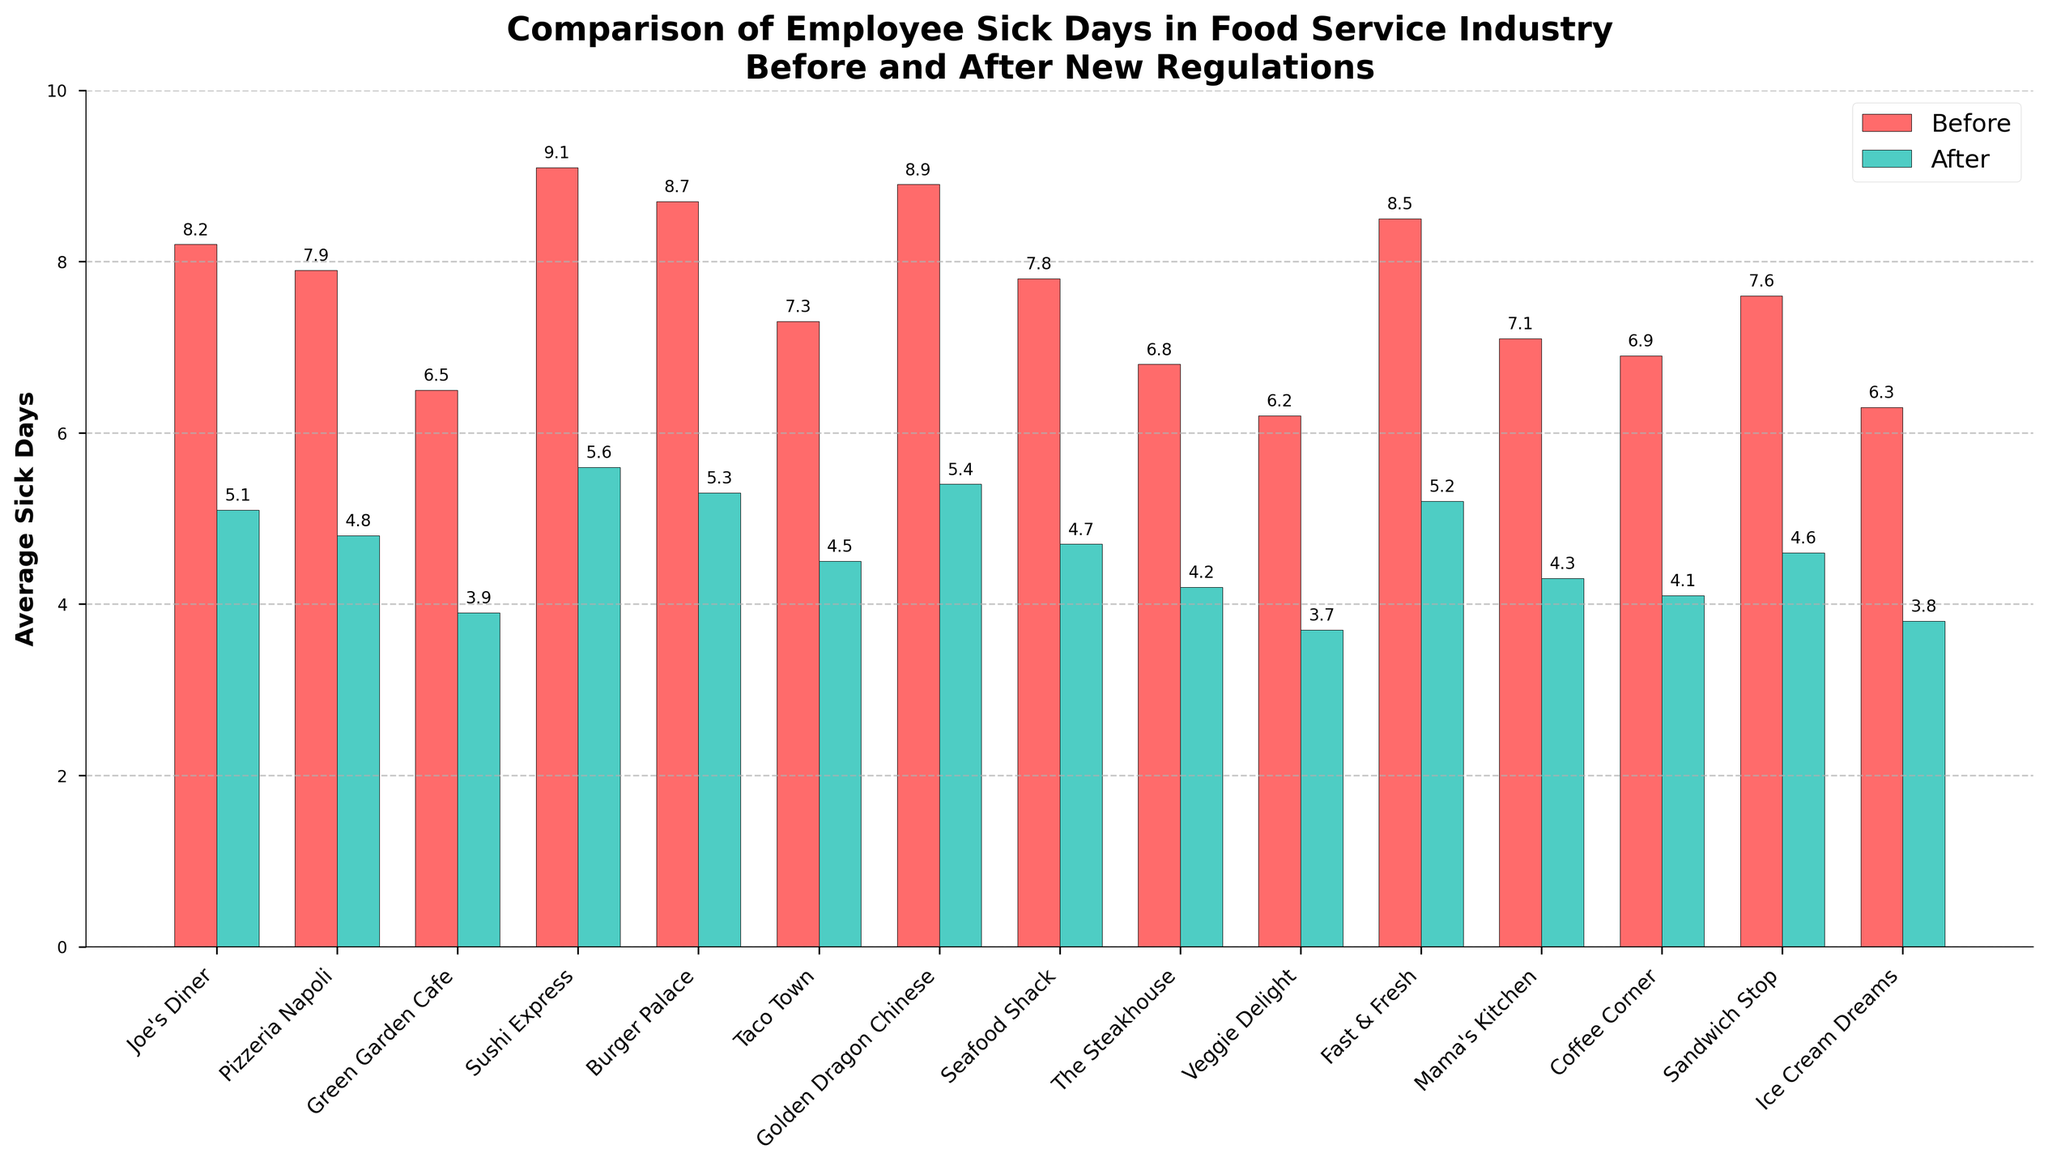What is the overall trend in average sick days before and after the new regulations across all restaurants? The plot shows that the height of the green bars (after regulations) is consistently lower than the height of the red bars (before regulations) for each restaurant, indicating a decrease in average sick days for all restaurants.
Answer: Decrease Which restaurant had the highest average sick days before the new regulations? Looking at the red bars, the tallest one corresponds to "Sushi Express," indicating it had the highest average sick days before the new regulations.
Answer: Sushi Express What was the average reduction in sick days for "Golden Dragon Chinese"? The red bar for "Golden Dragon Chinese" shows an average of 8.9 days before, and the green bar shows 5.4 days after. The reduction is calculated as 8.9 - 5.4.
Answer: 3.5 days Which restaurants had an average sick day reduction greater than 3 days? By comparing the height difference between red and green bars, "Joe's Diner," "Pizzeria Napoli," "Sushi Express," "Burger Palace," "Golden Dragon Chinese," and "Fast & Fresh" show reductions greater than 3 days.
Answer: Joe's Diner, Pizzeria Napoli, Sushi Express, Burger Palace, Golden Dragon Chinese, Fast & Fresh What is the approximate total average sick days saved after the implementation for all restaurants combined? Sum the average reduction in sick days for each restaurant: (8.2-5.1) + (7.9-4.8) + (6.5-3.9) + (9.1-5.6) + (8.7-5.3) + (7.3-4.5) + (8.9-5.4) + (7.8-4.7) + (6.8-4.2) + (6.2-3.7) + (8.5-5.2) + (7.1-4.3) + (6.9-4.1) + (7.6-4.6) + (6.3-3.8) = 47.5 days.
Answer: 47.5 days Which restaurant showed the smallest reduction in average sick days after the new regulations? The smallest height difference between red and green bars is seen for "Green Garden Cafe" which reduced from 6.5 to 3.9, a difference of 2.6 days.
Answer: Green Garden Cafe If a restaurant reduced its average sick days by 50%, how many sick days would that be if it initially had 8.2 average sick days? A 50% reduction of 8.2 sick days is calculated as 0.5 * 8.2.
Answer: 4.1 days By how many days did "The Steakhouse" reduce its average sick days? The red bar for "The Steakhouse" shows 6.8 days, and the green bar shows 4.2 days. The reduction is calculated as 6.8 - 4.2.
Answer: 2.6 days 